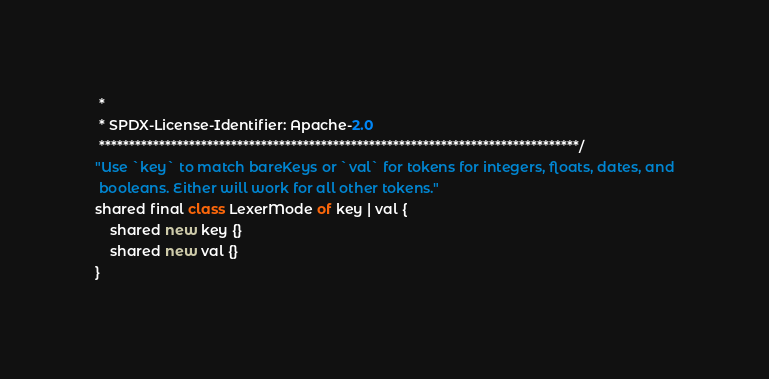Convert code to text. <code><loc_0><loc_0><loc_500><loc_500><_Ceylon_> *
 * SPDX-License-Identifier: Apache-2.0 
 ********************************************************************************/
"Use `key` to match bareKeys or `val` for tokens for integers, floats, dates, and
 booleans. Either will work for all other tokens."
shared final class LexerMode of key | val {
    shared new key {}
    shared new val {}
}
</code> 